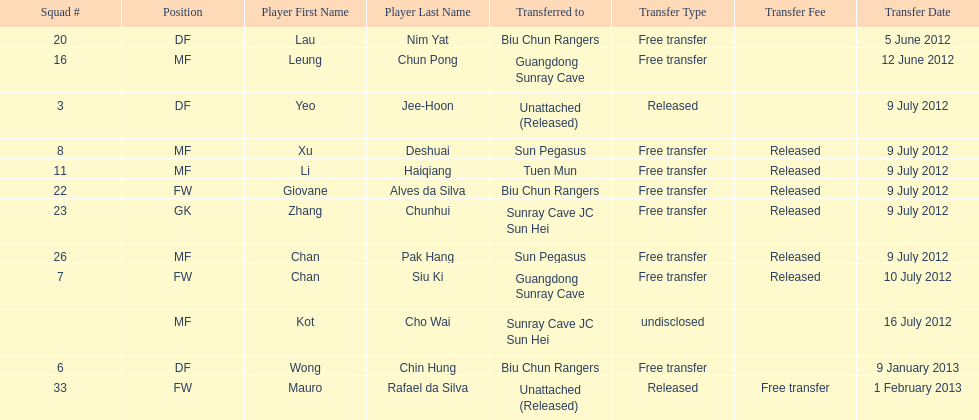Give me the full table as a dictionary. {'header': ['Squad #', 'Position', 'Player First Name', 'Player Last Name', 'Transferred to', 'Transfer Type', 'Transfer Fee', 'Transfer Date'], 'rows': [['20', 'DF', 'Lau', 'Nim Yat', 'Biu Chun Rangers', 'Free transfer', '', '5 June 2012'], ['16', 'MF', 'Leung', 'Chun Pong', 'Guangdong Sunray Cave', 'Free transfer', '', '12 June 2012'], ['3', 'DF', 'Yeo', 'Jee-Hoon', 'Unattached (Released)', 'Released', '', '9 July 2012'], ['8', 'MF', 'Xu', 'Deshuai', 'Sun Pegasus', 'Free transfer', 'Released', '9 July 2012'], ['11', 'MF', 'Li', 'Haiqiang', 'Tuen Mun', 'Free transfer', 'Released', '9 July 2012'], ['22', 'FW', 'Giovane', 'Alves da Silva', 'Biu Chun Rangers', 'Free transfer', 'Released', '9 July 2012'], ['23', 'GK', 'Zhang', 'Chunhui', 'Sunray Cave JC Sun Hei', 'Free transfer', 'Released', '9 July 2012'], ['26', 'MF', 'Chan', 'Pak Hang', 'Sun Pegasus', 'Free transfer', 'Released', '9 July 2012'], ['7', 'FW', 'Chan', 'Siu Ki', 'Guangdong Sunray Cave', 'Free transfer', 'Released', '10 July 2012'], ['', 'MF', 'Kot', 'Cho Wai', 'Sunray Cave JC Sun Hei', 'undisclosed', '', '16 July 2012'], ['6', 'DF', 'Wong', 'Chin Hung', 'Biu Chun Rangers', 'Free transfer', '', '9 January 2013'], ['33', 'FW', 'Mauro', 'Rafael da Silva', 'Unattached (Released)', 'Released', 'Free transfer', '1 February 2013']]} How many total players were transferred to sun pegasus? 2. 